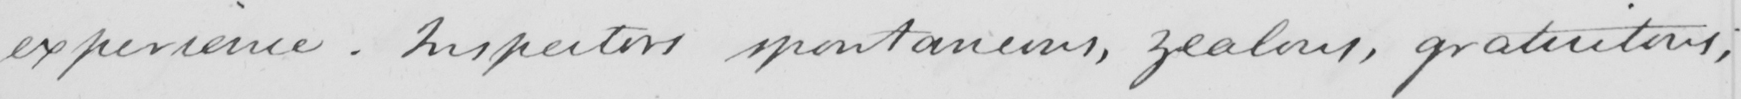Can you read and transcribe this handwriting? experience . Inspectors spontaneous , zealous , gratuitous ; 